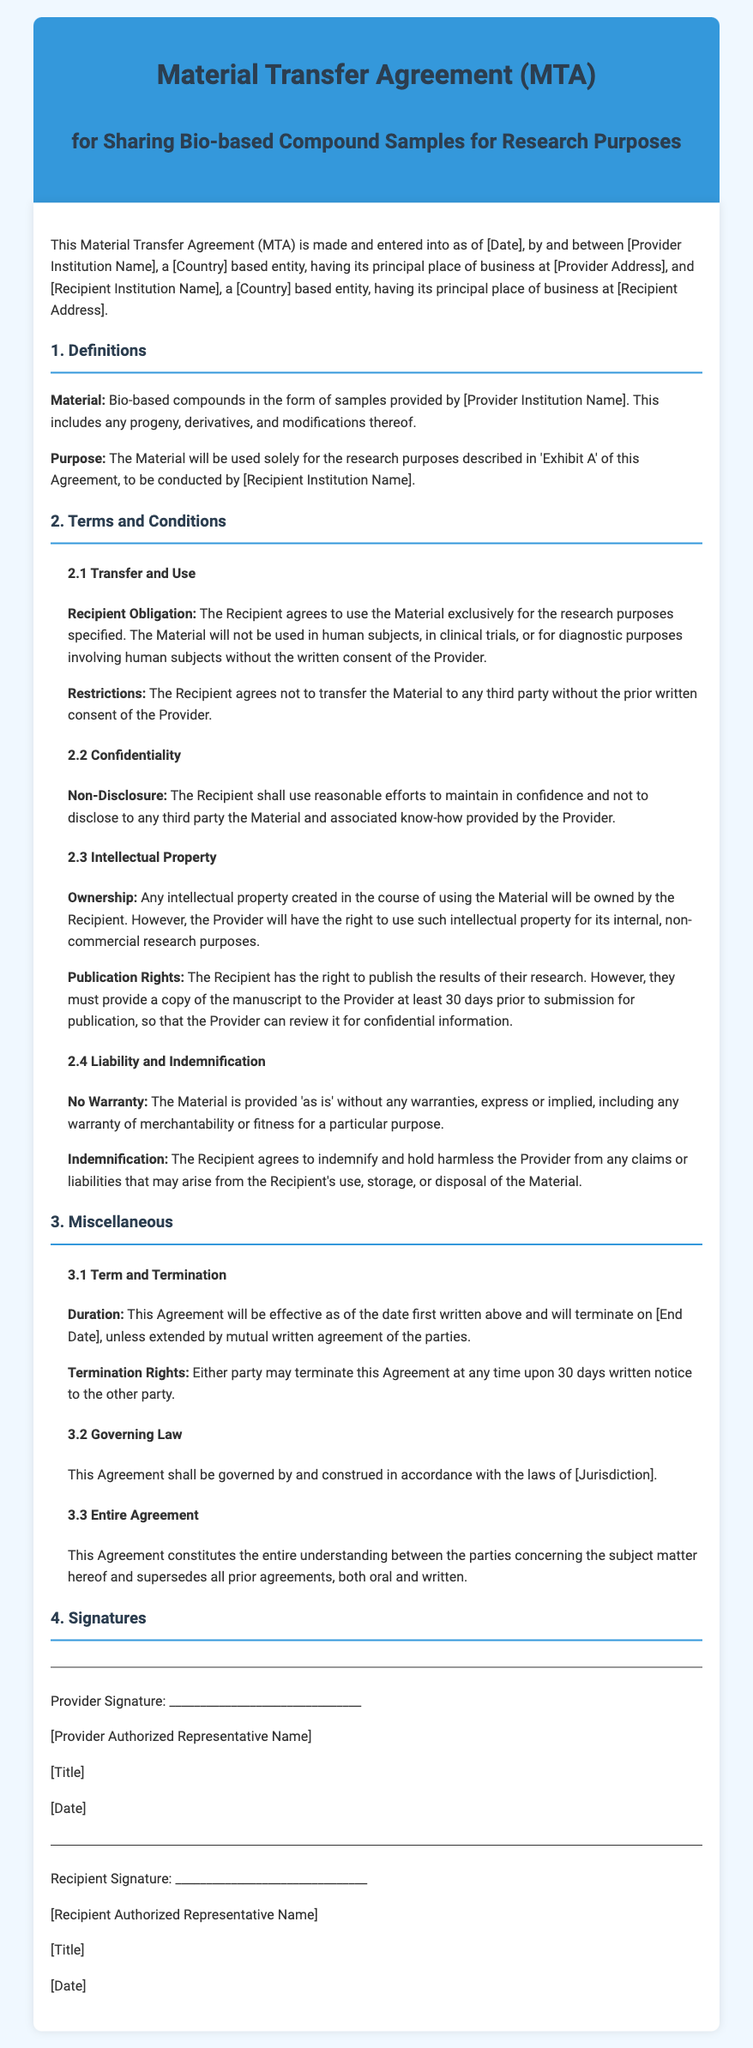What is the title of the document? The title is prominently displayed in the header of the document, indicating its purpose.
Answer: Material Transfer Agreement (MTA) Who are the parties involved in the agreement? The parties are listed in the introductory paragraph, specifying their roles as Provider and Recipient institutions.
Answer: [Provider Institution Name] and [Recipient Institution Name] What is the effective date of the agreement? The effective date is mentioned as "[Date]" in the introduction, which needs to be filled in.
Answer: [Date] What is the recipient's obligation regarding the material? This obligation is detailed in section 2.1, emphasizing the specific usage of the material provided.
Answer: Use exclusively for research purposes How long is the duration of the agreement? The duration is discussed in section 3.1, providing a general time frame for the agreement’s effectiveness.
Answer: [End Date] What must the recipient do before publishing research results? This requirement can be found in section 2.3, specifying the action the recipient needs to take regarding their manuscript.
Answer: Provide a copy of the manuscript What is the governing law for the agreement? The governing law is stated in section 3.2, outlining the legal jurisdiction that applies to the agreement.
Answer: [Jurisdiction] What does “No Warranty” imply regarding the material? The "No Warranty" clause explains the condition of the material provided, clarifying the provider's responsibility.
Answer: Provided 'as is' Who has the ownership of any intellectual property created? This is specifically stated in section 2.3, highlighting ownership rights related to research outputs.
Answer: Recipient 